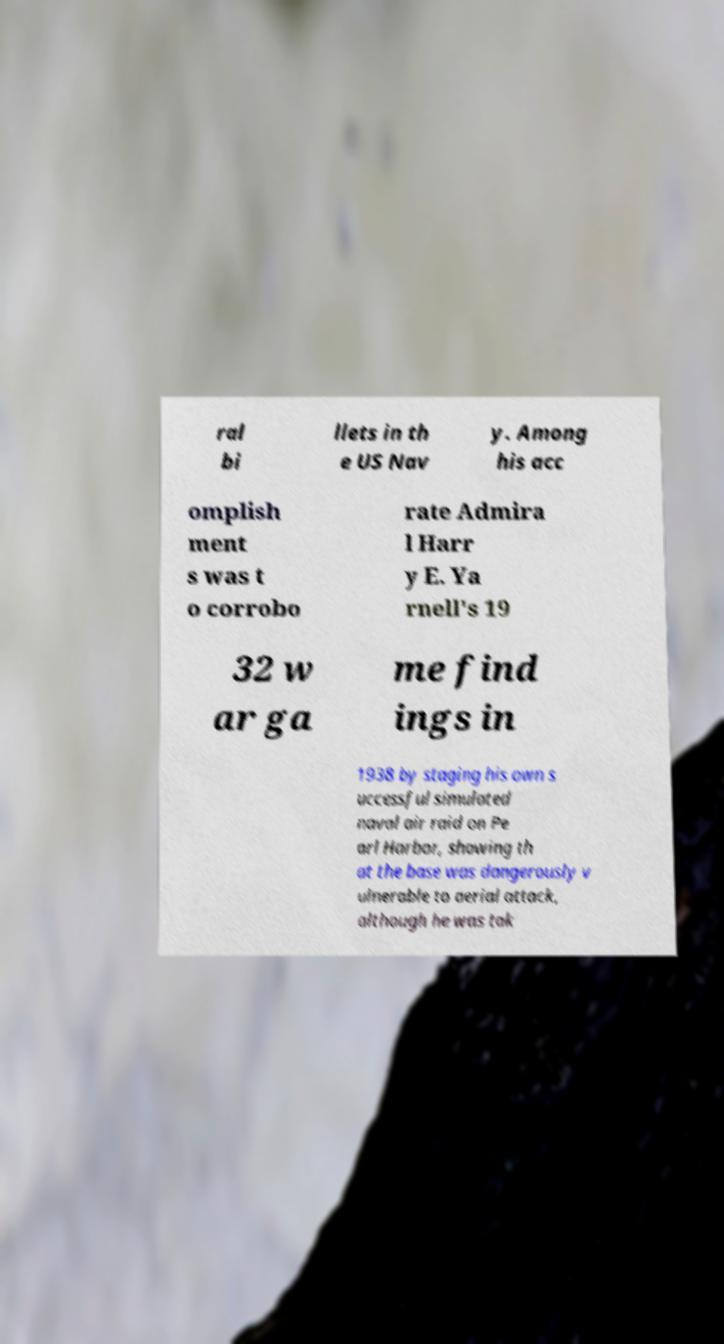Please identify and transcribe the text found in this image. ral bi llets in th e US Nav y. Among his acc omplish ment s was t o corrobo rate Admira l Harr y E. Ya rnell's 19 32 w ar ga me find ings in 1938 by staging his own s uccessful simulated naval air raid on Pe arl Harbor, showing th at the base was dangerously v ulnerable to aerial attack, although he was tak 